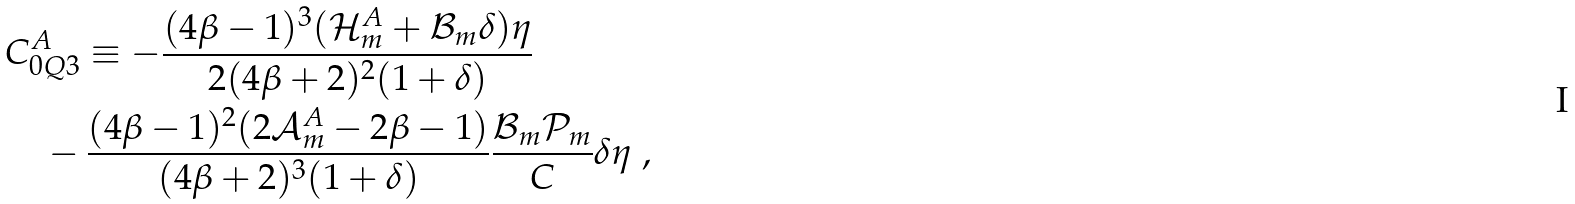Convert formula to latex. <formula><loc_0><loc_0><loc_500><loc_500>& C ^ { A } _ { 0 Q 3 } \equiv - \frac { ( 4 \beta - 1 ) ^ { 3 } ( \mathcal { H } ^ { A } _ { m } + \mathcal { B } _ { m } \delta ) \eta } { 2 ( 4 \beta + 2 ) ^ { 2 } ( 1 + \delta ) } \\ & \quad - \frac { ( 4 \beta - 1 ) ^ { 2 } ( 2 \mathcal { A } ^ { A } _ { m } - 2 \beta - 1 ) } { ( 4 \beta + 2 ) ^ { 3 } ( 1 + \delta ) } \frac { \mathcal { B } _ { m } \mathcal { P } _ { m } } { C } \delta \eta \ , \\</formula> 